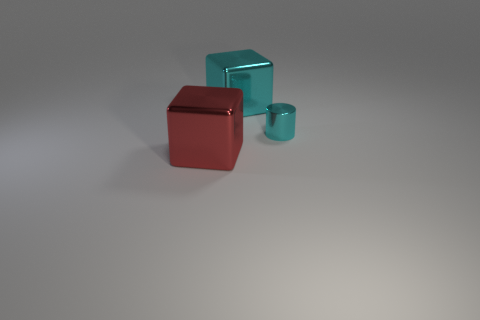Add 2 cyan cylinders. How many objects exist? 5 Subtract all blocks. How many objects are left? 1 Subtract all big cyan metallic cubes. Subtract all red shiny things. How many objects are left? 1 Add 3 tiny cyan cylinders. How many tiny cyan cylinders are left? 4 Add 3 large things. How many large things exist? 5 Subtract 0 red spheres. How many objects are left? 3 